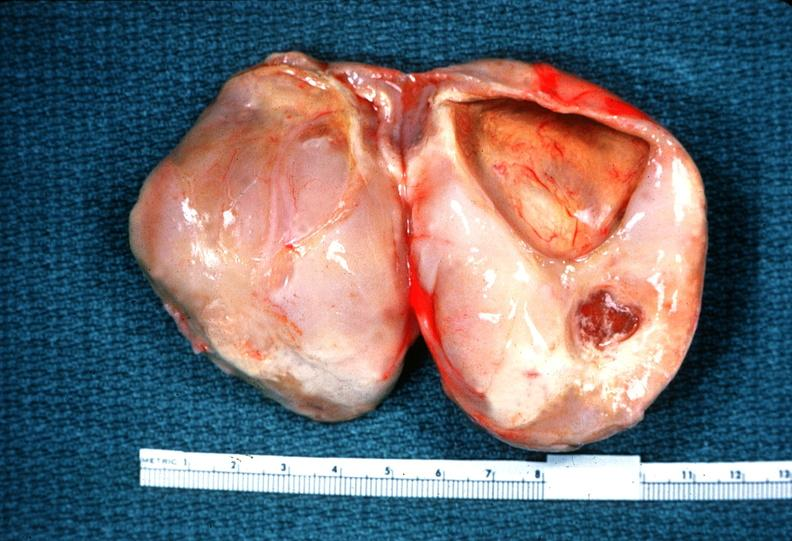does abruption show schwannoma?
Answer the question using a single word or phrase. No 